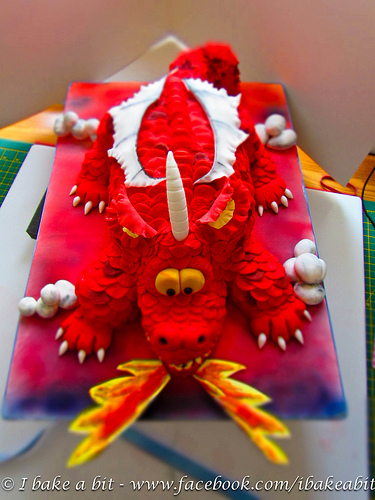<image>
Is there a flame behind the animal? No. The flame is not behind the animal. From this viewpoint, the flame appears to be positioned elsewhere in the scene. 